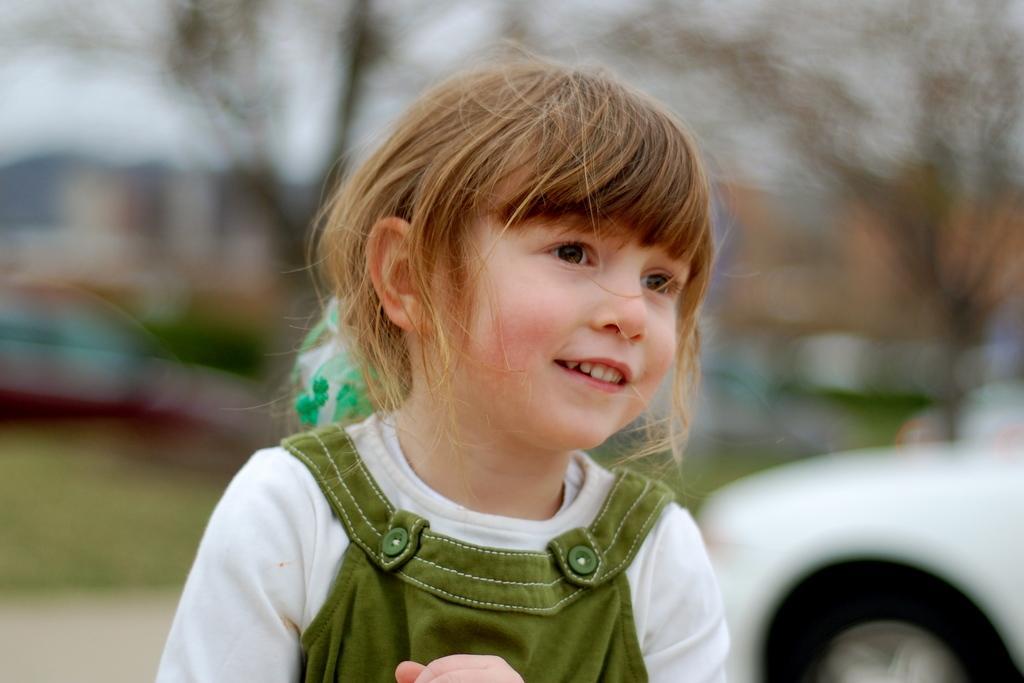Can you describe this image briefly? In this image we can see a girl. On the right side, we can see a vehicle. The background of the image is blurred. 